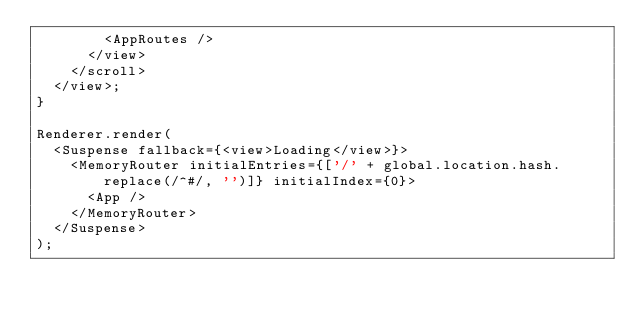<code> <loc_0><loc_0><loc_500><loc_500><_TypeScript_>        <AppRoutes />
      </view>
    </scroll>
  </view>;
}

Renderer.render(
  <Suspense fallback={<view>Loading</view>}>
    <MemoryRouter initialEntries={['/' + global.location.hash.replace(/^#/, '')]} initialIndex={0}>
      <App />
    </MemoryRouter>
  </Suspense>
);
</code> 